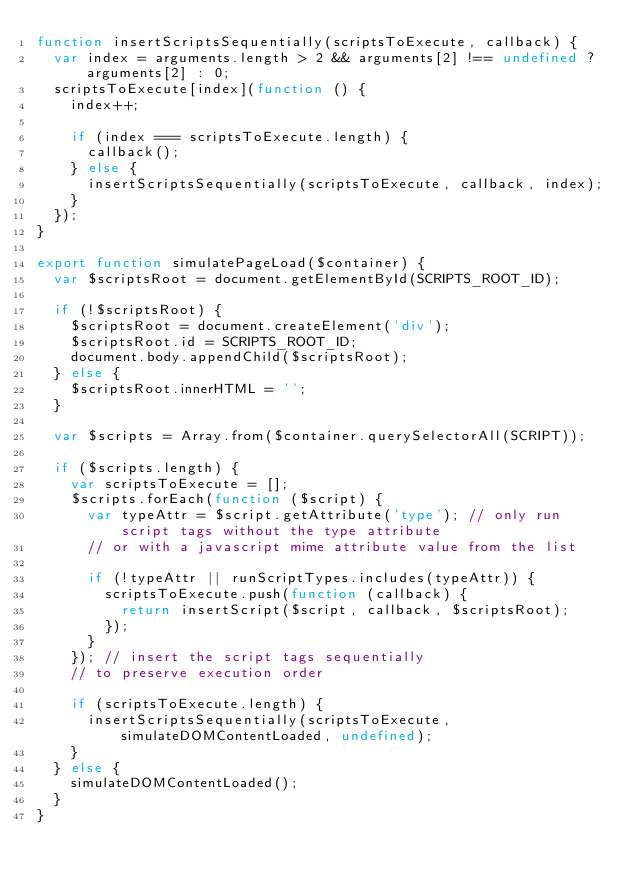Convert code to text. <code><loc_0><loc_0><loc_500><loc_500><_JavaScript_>function insertScriptsSequentially(scriptsToExecute, callback) {
  var index = arguments.length > 2 && arguments[2] !== undefined ? arguments[2] : 0;
  scriptsToExecute[index](function () {
    index++;

    if (index === scriptsToExecute.length) {
      callback();
    } else {
      insertScriptsSequentially(scriptsToExecute, callback, index);
    }
  });
}

export function simulatePageLoad($container) {
  var $scriptsRoot = document.getElementById(SCRIPTS_ROOT_ID);

  if (!$scriptsRoot) {
    $scriptsRoot = document.createElement('div');
    $scriptsRoot.id = SCRIPTS_ROOT_ID;
    document.body.appendChild($scriptsRoot);
  } else {
    $scriptsRoot.innerHTML = '';
  }

  var $scripts = Array.from($container.querySelectorAll(SCRIPT));

  if ($scripts.length) {
    var scriptsToExecute = [];
    $scripts.forEach(function ($script) {
      var typeAttr = $script.getAttribute('type'); // only run script tags without the type attribute
      // or with a javascript mime attribute value from the list

      if (!typeAttr || runScriptTypes.includes(typeAttr)) {
        scriptsToExecute.push(function (callback) {
          return insertScript($script, callback, $scriptsRoot);
        });
      }
    }); // insert the script tags sequentially
    // to preserve execution order

    if (scriptsToExecute.length) {
      insertScriptsSequentially(scriptsToExecute, simulateDOMContentLoaded, undefined);
    }
  } else {
    simulateDOMContentLoaded();
  }
}</code> 